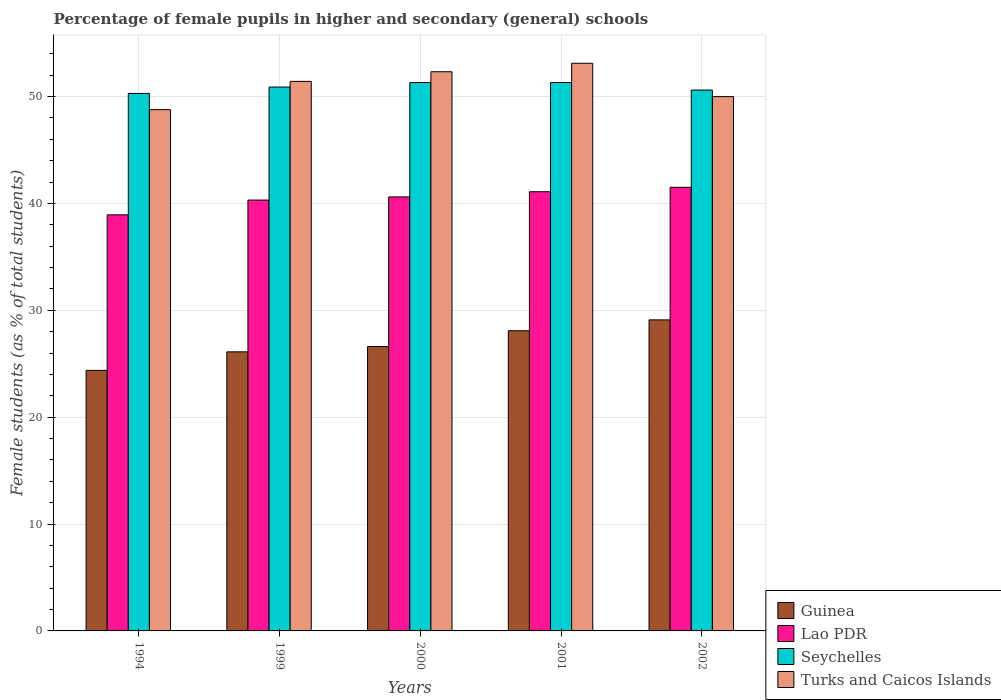How many different coloured bars are there?
Ensure brevity in your answer.  4. Are the number of bars on each tick of the X-axis equal?
Make the answer very short. Yes. How many bars are there on the 2nd tick from the left?
Give a very brief answer. 4. How many bars are there on the 1st tick from the right?
Your response must be concise. 4. What is the label of the 4th group of bars from the left?
Ensure brevity in your answer.  2001. What is the percentage of female pupils in higher and secondary schools in Turks and Caicos Islands in 1994?
Make the answer very short. 48.78. Across all years, what is the maximum percentage of female pupils in higher and secondary schools in Guinea?
Your answer should be very brief. 29.11. Across all years, what is the minimum percentage of female pupils in higher and secondary schools in Guinea?
Your answer should be very brief. 24.38. In which year was the percentage of female pupils in higher and secondary schools in Seychelles maximum?
Make the answer very short. 2000. In which year was the percentage of female pupils in higher and secondary schools in Turks and Caicos Islands minimum?
Ensure brevity in your answer.  1994. What is the total percentage of female pupils in higher and secondary schools in Guinea in the graph?
Your answer should be very brief. 134.31. What is the difference between the percentage of female pupils in higher and secondary schools in Seychelles in 2000 and that in 2001?
Ensure brevity in your answer.  0. What is the difference between the percentage of female pupils in higher and secondary schools in Turks and Caicos Islands in 2002 and the percentage of female pupils in higher and secondary schools in Guinea in 1999?
Offer a terse response. 23.88. What is the average percentage of female pupils in higher and secondary schools in Guinea per year?
Offer a terse response. 26.86. In the year 2000, what is the difference between the percentage of female pupils in higher and secondary schools in Turks and Caicos Islands and percentage of female pupils in higher and secondary schools in Seychelles?
Provide a short and direct response. 1.01. In how many years, is the percentage of female pupils in higher and secondary schools in Guinea greater than 14 %?
Give a very brief answer. 5. What is the ratio of the percentage of female pupils in higher and secondary schools in Lao PDR in 1999 to that in 2002?
Give a very brief answer. 0.97. What is the difference between the highest and the second highest percentage of female pupils in higher and secondary schools in Turks and Caicos Islands?
Ensure brevity in your answer.  0.79. What is the difference between the highest and the lowest percentage of female pupils in higher and secondary schools in Guinea?
Your response must be concise. 4.73. In how many years, is the percentage of female pupils in higher and secondary schools in Seychelles greater than the average percentage of female pupils in higher and secondary schools in Seychelles taken over all years?
Offer a very short reply. 3. What does the 1st bar from the left in 2002 represents?
Make the answer very short. Guinea. What does the 3rd bar from the right in 2002 represents?
Provide a short and direct response. Lao PDR. How many bars are there?
Your response must be concise. 20. What is the difference between two consecutive major ticks on the Y-axis?
Ensure brevity in your answer.  10. Are the values on the major ticks of Y-axis written in scientific E-notation?
Provide a succinct answer. No. Does the graph contain any zero values?
Your answer should be very brief. No. How are the legend labels stacked?
Offer a terse response. Vertical. What is the title of the graph?
Your answer should be compact. Percentage of female pupils in higher and secondary (general) schools. What is the label or title of the X-axis?
Give a very brief answer. Years. What is the label or title of the Y-axis?
Offer a very short reply. Female students (as % of total students). What is the Female students (as % of total students) of Guinea in 1994?
Offer a very short reply. 24.38. What is the Female students (as % of total students) in Lao PDR in 1994?
Offer a terse response. 38.94. What is the Female students (as % of total students) in Seychelles in 1994?
Provide a short and direct response. 50.3. What is the Female students (as % of total students) in Turks and Caicos Islands in 1994?
Provide a succinct answer. 48.78. What is the Female students (as % of total students) of Guinea in 1999?
Provide a short and direct response. 26.12. What is the Female students (as % of total students) of Lao PDR in 1999?
Offer a very short reply. 40.32. What is the Female students (as % of total students) of Seychelles in 1999?
Offer a very short reply. 50.9. What is the Female students (as % of total students) in Turks and Caicos Islands in 1999?
Offer a terse response. 51.43. What is the Female students (as % of total students) of Guinea in 2000?
Provide a short and direct response. 26.61. What is the Female students (as % of total students) in Lao PDR in 2000?
Keep it short and to the point. 40.62. What is the Female students (as % of total students) of Seychelles in 2000?
Provide a short and direct response. 51.32. What is the Female students (as % of total students) of Turks and Caicos Islands in 2000?
Your answer should be very brief. 52.33. What is the Female students (as % of total students) of Guinea in 2001?
Offer a very short reply. 28.09. What is the Female students (as % of total students) of Lao PDR in 2001?
Provide a short and direct response. 41.1. What is the Female students (as % of total students) in Seychelles in 2001?
Your answer should be compact. 51.32. What is the Female students (as % of total students) of Turks and Caicos Islands in 2001?
Make the answer very short. 53.12. What is the Female students (as % of total students) in Guinea in 2002?
Ensure brevity in your answer.  29.11. What is the Female students (as % of total students) in Lao PDR in 2002?
Your answer should be very brief. 41.52. What is the Female students (as % of total students) in Seychelles in 2002?
Provide a short and direct response. 50.61. What is the Female students (as % of total students) in Turks and Caicos Islands in 2002?
Provide a succinct answer. 50. Across all years, what is the maximum Female students (as % of total students) of Guinea?
Offer a very short reply. 29.11. Across all years, what is the maximum Female students (as % of total students) in Lao PDR?
Offer a terse response. 41.52. Across all years, what is the maximum Female students (as % of total students) in Seychelles?
Make the answer very short. 51.32. Across all years, what is the maximum Female students (as % of total students) of Turks and Caicos Islands?
Ensure brevity in your answer.  53.12. Across all years, what is the minimum Female students (as % of total students) of Guinea?
Make the answer very short. 24.38. Across all years, what is the minimum Female students (as % of total students) of Lao PDR?
Your response must be concise. 38.94. Across all years, what is the minimum Female students (as % of total students) of Seychelles?
Make the answer very short. 50.3. Across all years, what is the minimum Female students (as % of total students) of Turks and Caicos Islands?
Ensure brevity in your answer.  48.78. What is the total Female students (as % of total students) in Guinea in the graph?
Give a very brief answer. 134.31. What is the total Female students (as % of total students) of Lao PDR in the graph?
Make the answer very short. 202.49. What is the total Female students (as % of total students) in Seychelles in the graph?
Make the answer very short. 254.44. What is the total Female students (as % of total students) in Turks and Caicos Islands in the graph?
Keep it short and to the point. 255.66. What is the difference between the Female students (as % of total students) of Guinea in 1994 and that in 1999?
Your answer should be very brief. -1.73. What is the difference between the Female students (as % of total students) in Lao PDR in 1994 and that in 1999?
Provide a short and direct response. -1.38. What is the difference between the Female students (as % of total students) in Seychelles in 1994 and that in 1999?
Offer a very short reply. -0.6. What is the difference between the Female students (as % of total students) of Turks and Caicos Islands in 1994 and that in 1999?
Give a very brief answer. -2.65. What is the difference between the Female students (as % of total students) in Guinea in 1994 and that in 2000?
Ensure brevity in your answer.  -2.23. What is the difference between the Female students (as % of total students) in Lao PDR in 1994 and that in 2000?
Ensure brevity in your answer.  -1.68. What is the difference between the Female students (as % of total students) in Seychelles in 1994 and that in 2000?
Provide a succinct answer. -1.02. What is the difference between the Female students (as % of total students) of Turks and Caicos Islands in 1994 and that in 2000?
Offer a terse response. -3.55. What is the difference between the Female students (as % of total students) in Guinea in 1994 and that in 2001?
Your answer should be compact. -3.71. What is the difference between the Female students (as % of total students) in Lao PDR in 1994 and that in 2001?
Offer a very short reply. -2.16. What is the difference between the Female students (as % of total students) of Seychelles in 1994 and that in 2001?
Offer a very short reply. -1.02. What is the difference between the Female students (as % of total students) in Turks and Caicos Islands in 1994 and that in 2001?
Your answer should be compact. -4.34. What is the difference between the Female students (as % of total students) in Guinea in 1994 and that in 2002?
Your answer should be very brief. -4.73. What is the difference between the Female students (as % of total students) of Lao PDR in 1994 and that in 2002?
Your answer should be very brief. -2.58. What is the difference between the Female students (as % of total students) in Seychelles in 1994 and that in 2002?
Your answer should be compact. -0.32. What is the difference between the Female students (as % of total students) in Turks and Caicos Islands in 1994 and that in 2002?
Offer a terse response. -1.22. What is the difference between the Female students (as % of total students) of Guinea in 1999 and that in 2000?
Your answer should be compact. -0.5. What is the difference between the Female students (as % of total students) of Lao PDR in 1999 and that in 2000?
Give a very brief answer. -0.3. What is the difference between the Female students (as % of total students) of Seychelles in 1999 and that in 2000?
Offer a very short reply. -0.42. What is the difference between the Female students (as % of total students) of Turks and Caicos Islands in 1999 and that in 2000?
Provide a short and direct response. -0.9. What is the difference between the Female students (as % of total students) of Guinea in 1999 and that in 2001?
Provide a short and direct response. -1.98. What is the difference between the Female students (as % of total students) of Lao PDR in 1999 and that in 2001?
Offer a terse response. -0.78. What is the difference between the Female students (as % of total students) in Seychelles in 1999 and that in 2001?
Provide a short and direct response. -0.42. What is the difference between the Female students (as % of total students) of Turks and Caicos Islands in 1999 and that in 2001?
Your answer should be compact. -1.7. What is the difference between the Female students (as % of total students) in Guinea in 1999 and that in 2002?
Make the answer very short. -2.99. What is the difference between the Female students (as % of total students) in Lao PDR in 1999 and that in 2002?
Offer a very short reply. -1.2. What is the difference between the Female students (as % of total students) in Seychelles in 1999 and that in 2002?
Your response must be concise. 0.28. What is the difference between the Female students (as % of total students) in Turks and Caicos Islands in 1999 and that in 2002?
Your response must be concise. 1.43. What is the difference between the Female students (as % of total students) of Guinea in 2000 and that in 2001?
Keep it short and to the point. -1.48. What is the difference between the Female students (as % of total students) of Lao PDR in 2000 and that in 2001?
Your answer should be very brief. -0.48. What is the difference between the Female students (as % of total students) in Seychelles in 2000 and that in 2001?
Offer a terse response. 0. What is the difference between the Female students (as % of total students) in Turks and Caicos Islands in 2000 and that in 2001?
Make the answer very short. -0.79. What is the difference between the Female students (as % of total students) of Guinea in 2000 and that in 2002?
Make the answer very short. -2.49. What is the difference between the Female students (as % of total students) of Lao PDR in 2000 and that in 2002?
Your answer should be compact. -0.9. What is the difference between the Female students (as % of total students) of Seychelles in 2000 and that in 2002?
Your answer should be very brief. 0.7. What is the difference between the Female students (as % of total students) in Turks and Caicos Islands in 2000 and that in 2002?
Provide a short and direct response. 2.33. What is the difference between the Female students (as % of total students) in Guinea in 2001 and that in 2002?
Make the answer very short. -1.01. What is the difference between the Female students (as % of total students) in Lao PDR in 2001 and that in 2002?
Your response must be concise. -0.42. What is the difference between the Female students (as % of total students) in Seychelles in 2001 and that in 2002?
Your answer should be very brief. 0.7. What is the difference between the Female students (as % of total students) of Turks and Caicos Islands in 2001 and that in 2002?
Keep it short and to the point. 3.12. What is the difference between the Female students (as % of total students) in Guinea in 1994 and the Female students (as % of total students) in Lao PDR in 1999?
Make the answer very short. -15.94. What is the difference between the Female students (as % of total students) of Guinea in 1994 and the Female students (as % of total students) of Seychelles in 1999?
Give a very brief answer. -26.51. What is the difference between the Female students (as % of total students) of Guinea in 1994 and the Female students (as % of total students) of Turks and Caicos Islands in 1999?
Ensure brevity in your answer.  -27.04. What is the difference between the Female students (as % of total students) of Lao PDR in 1994 and the Female students (as % of total students) of Seychelles in 1999?
Ensure brevity in your answer.  -11.96. What is the difference between the Female students (as % of total students) in Lao PDR in 1994 and the Female students (as % of total students) in Turks and Caicos Islands in 1999?
Make the answer very short. -12.49. What is the difference between the Female students (as % of total students) of Seychelles in 1994 and the Female students (as % of total students) of Turks and Caicos Islands in 1999?
Keep it short and to the point. -1.13. What is the difference between the Female students (as % of total students) of Guinea in 1994 and the Female students (as % of total students) of Lao PDR in 2000?
Your response must be concise. -16.23. What is the difference between the Female students (as % of total students) in Guinea in 1994 and the Female students (as % of total students) in Seychelles in 2000?
Make the answer very short. -26.93. What is the difference between the Female students (as % of total students) of Guinea in 1994 and the Female students (as % of total students) of Turks and Caicos Islands in 2000?
Offer a terse response. -27.95. What is the difference between the Female students (as % of total students) in Lao PDR in 1994 and the Female students (as % of total students) in Seychelles in 2000?
Provide a short and direct response. -12.38. What is the difference between the Female students (as % of total students) in Lao PDR in 1994 and the Female students (as % of total students) in Turks and Caicos Islands in 2000?
Make the answer very short. -13.39. What is the difference between the Female students (as % of total students) of Seychelles in 1994 and the Female students (as % of total students) of Turks and Caicos Islands in 2000?
Your answer should be very brief. -2.03. What is the difference between the Female students (as % of total students) in Guinea in 1994 and the Female students (as % of total students) in Lao PDR in 2001?
Offer a terse response. -16.72. What is the difference between the Female students (as % of total students) of Guinea in 1994 and the Female students (as % of total students) of Seychelles in 2001?
Keep it short and to the point. -26.93. What is the difference between the Female students (as % of total students) of Guinea in 1994 and the Female students (as % of total students) of Turks and Caicos Islands in 2001?
Offer a very short reply. -28.74. What is the difference between the Female students (as % of total students) in Lao PDR in 1994 and the Female students (as % of total students) in Seychelles in 2001?
Give a very brief answer. -12.38. What is the difference between the Female students (as % of total students) of Lao PDR in 1994 and the Female students (as % of total students) of Turks and Caicos Islands in 2001?
Keep it short and to the point. -14.19. What is the difference between the Female students (as % of total students) of Seychelles in 1994 and the Female students (as % of total students) of Turks and Caicos Islands in 2001?
Provide a short and direct response. -2.82. What is the difference between the Female students (as % of total students) in Guinea in 1994 and the Female students (as % of total students) in Lao PDR in 2002?
Offer a very short reply. -17.13. What is the difference between the Female students (as % of total students) of Guinea in 1994 and the Female students (as % of total students) of Seychelles in 2002?
Your answer should be very brief. -26.23. What is the difference between the Female students (as % of total students) of Guinea in 1994 and the Female students (as % of total students) of Turks and Caicos Islands in 2002?
Keep it short and to the point. -25.62. What is the difference between the Female students (as % of total students) of Lao PDR in 1994 and the Female students (as % of total students) of Seychelles in 2002?
Provide a succinct answer. -11.68. What is the difference between the Female students (as % of total students) of Lao PDR in 1994 and the Female students (as % of total students) of Turks and Caicos Islands in 2002?
Your response must be concise. -11.06. What is the difference between the Female students (as % of total students) of Seychelles in 1994 and the Female students (as % of total students) of Turks and Caicos Islands in 2002?
Keep it short and to the point. 0.3. What is the difference between the Female students (as % of total students) of Guinea in 1999 and the Female students (as % of total students) of Lao PDR in 2000?
Your answer should be very brief. -14.5. What is the difference between the Female students (as % of total students) of Guinea in 1999 and the Female students (as % of total students) of Seychelles in 2000?
Provide a short and direct response. -25.2. What is the difference between the Female students (as % of total students) in Guinea in 1999 and the Female students (as % of total students) in Turks and Caicos Islands in 2000?
Provide a succinct answer. -26.21. What is the difference between the Female students (as % of total students) in Lao PDR in 1999 and the Female students (as % of total students) in Seychelles in 2000?
Offer a very short reply. -11. What is the difference between the Female students (as % of total students) in Lao PDR in 1999 and the Female students (as % of total students) in Turks and Caicos Islands in 2000?
Offer a terse response. -12.01. What is the difference between the Female students (as % of total students) of Seychelles in 1999 and the Female students (as % of total students) of Turks and Caicos Islands in 2000?
Your response must be concise. -1.43. What is the difference between the Female students (as % of total students) of Guinea in 1999 and the Female students (as % of total students) of Lao PDR in 2001?
Offer a very short reply. -14.98. What is the difference between the Female students (as % of total students) in Guinea in 1999 and the Female students (as % of total students) in Seychelles in 2001?
Make the answer very short. -25.2. What is the difference between the Female students (as % of total students) in Guinea in 1999 and the Female students (as % of total students) in Turks and Caicos Islands in 2001?
Provide a succinct answer. -27.01. What is the difference between the Female students (as % of total students) of Lao PDR in 1999 and the Female students (as % of total students) of Seychelles in 2001?
Provide a short and direct response. -11. What is the difference between the Female students (as % of total students) in Lao PDR in 1999 and the Female students (as % of total students) in Turks and Caicos Islands in 2001?
Ensure brevity in your answer.  -12.8. What is the difference between the Female students (as % of total students) of Seychelles in 1999 and the Female students (as % of total students) of Turks and Caicos Islands in 2001?
Keep it short and to the point. -2.23. What is the difference between the Female students (as % of total students) in Guinea in 1999 and the Female students (as % of total students) in Lao PDR in 2002?
Provide a short and direct response. -15.4. What is the difference between the Female students (as % of total students) in Guinea in 1999 and the Female students (as % of total students) in Seychelles in 2002?
Keep it short and to the point. -24.5. What is the difference between the Female students (as % of total students) of Guinea in 1999 and the Female students (as % of total students) of Turks and Caicos Islands in 2002?
Your answer should be compact. -23.88. What is the difference between the Female students (as % of total students) in Lao PDR in 1999 and the Female students (as % of total students) in Seychelles in 2002?
Provide a succinct answer. -10.29. What is the difference between the Female students (as % of total students) in Lao PDR in 1999 and the Female students (as % of total students) in Turks and Caicos Islands in 2002?
Provide a short and direct response. -9.68. What is the difference between the Female students (as % of total students) in Seychelles in 1999 and the Female students (as % of total students) in Turks and Caicos Islands in 2002?
Provide a succinct answer. 0.9. What is the difference between the Female students (as % of total students) of Guinea in 2000 and the Female students (as % of total students) of Lao PDR in 2001?
Give a very brief answer. -14.49. What is the difference between the Female students (as % of total students) in Guinea in 2000 and the Female students (as % of total students) in Seychelles in 2001?
Your response must be concise. -24.7. What is the difference between the Female students (as % of total students) in Guinea in 2000 and the Female students (as % of total students) in Turks and Caicos Islands in 2001?
Make the answer very short. -26.51. What is the difference between the Female students (as % of total students) in Lao PDR in 2000 and the Female students (as % of total students) in Seychelles in 2001?
Give a very brief answer. -10.7. What is the difference between the Female students (as % of total students) of Lao PDR in 2000 and the Female students (as % of total students) of Turks and Caicos Islands in 2001?
Ensure brevity in your answer.  -12.51. What is the difference between the Female students (as % of total students) in Seychelles in 2000 and the Female students (as % of total students) in Turks and Caicos Islands in 2001?
Provide a short and direct response. -1.81. What is the difference between the Female students (as % of total students) of Guinea in 2000 and the Female students (as % of total students) of Lao PDR in 2002?
Offer a terse response. -14.9. What is the difference between the Female students (as % of total students) in Guinea in 2000 and the Female students (as % of total students) in Seychelles in 2002?
Offer a terse response. -24. What is the difference between the Female students (as % of total students) in Guinea in 2000 and the Female students (as % of total students) in Turks and Caicos Islands in 2002?
Keep it short and to the point. -23.39. What is the difference between the Female students (as % of total students) in Lao PDR in 2000 and the Female students (as % of total students) in Seychelles in 2002?
Your answer should be compact. -10. What is the difference between the Female students (as % of total students) of Lao PDR in 2000 and the Female students (as % of total students) of Turks and Caicos Islands in 2002?
Your answer should be very brief. -9.38. What is the difference between the Female students (as % of total students) in Seychelles in 2000 and the Female students (as % of total students) in Turks and Caicos Islands in 2002?
Provide a succinct answer. 1.32. What is the difference between the Female students (as % of total students) in Guinea in 2001 and the Female students (as % of total students) in Lao PDR in 2002?
Keep it short and to the point. -13.42. What is the difference between the Female students (as % of total students) of Guinea in 2001 and the Female students (as % of total students) of Seychelles in 2002?
Offer a terse response. -22.52. What is the difference between the Female students (as % of total students) of Guinea in 2001 and the Female students (as % of total students) of Turks and Caicos Islands in 2002?
Your answer should be compact. -21.91. What is the difference between the Female students (as % of total students) of Lao PDR in 2001 and the Female students (as % of total students) of Seychelles in 2002?
Ensure brevity in your answer.  -9.51. What is the difference between the Female students (as % of total students) in Seychelles in 2001 and the Female students (as % of total students) in Turks and Caicos Islands in 2002?
Give a very brief answer. 1.32. What is the average Female students (as % of total students) in Guinea per year?
Provide a short and direct response. 26.86. What is the average Female students (as % of total students) in Lao PDR per year?
Ensure brevity in your answer.  40.5. What is the average Female students (as % of total students) of Seychelles per year?
Your answer should be very brief. 50.89. What is the average Female students (as % of total students) of Turks and Caicos Islands per year?
Your answer should be very brief. 51.13. In the year 1994, what is the difference between the Female students (as % of total students) in Guinea and Female students (as % of total students) in Lao PDR?
Provide a succinct answer. -14.56. In the year 1994, what is the difference between the Female students (as % of total students) in Guinea and Female students (as % of total students) in Seychelles?
Offer a terse response. -25.92. In the year 1994, what is the difference between the Female students (as % of total students) of Guinea and Female students (as % of total students) of Turks and Caicos Islands?
Provide a short and direct response. -24.4. In the year 1994, what is the difference between the Female students (as % of total students) in Lao PDR and Female students (as % of total students) in Seychelles?
Your response must be concise. -11.36. In the year 1994, what is the difference between the Female students (as % of total students) of Lao PDR and Female students (as % of total students) of Turks and Caicos Islands?
Offer a terse response. -9.84. In the year 1994, what is the difference between the Female students (as % of total students) of Seychelles and Female students (as % of total students) of Turks and Caicos Islands?
Offer a very short reply. 1.52. In the year 1999, what is the difference between the Female students (as % of total students) of Guinea and Female students (as % of total students) of Lao PDR?
Provide a short and direct response. -14.2. In the year 1999, what is the difference between the Female students (as % of total students) in Guinea and Female students (as % of total students) in Seychelles?
Ensure brevity in your answer.  -24.78. In the year 1999, what is the difference between the Female students (as % of total students) of Guinea and Female students (as % of total students) of Turks and Caicos Islands?
Your answer should be compact. -25.31. In the year 1999, what is the difference between the Female students (as % of total students) of Lao PDR and Female students (as % of total students) of Seychelles?
Provide a succinct answer. -10.58. In the year 1999, what is the difference between the Female students (as % of total students) of Lao PDR and Female students (as % of total students) of Turks and Caicos Islands?
Your answer should be very brief. -11.11. In the year 1999, what is the difference between the Female students (as % of total students) in Seychelles and Female students (as % of total students) in Turks and Caicos Islands?
Keep it short and to the point. -0.53. In the year 2000, what is the difference between the Female students (as % of total students) of Guinea and Female students (as % of total students) of Lao PDR?
Keep it short and to the point. -14. In the year 2000, what is the difference between the Female students (as % of total students) in Guinea and Female students (as % of total students) in Seychelles?
Offer a terse response. -24.7. In the year 2000, what is the difference between the Female students (as % of total students) of Guinea and Female students (as % of total students) of Turks and Caicos Islands?
Offer a very short reply. -25.72. In the year 2000, what is the difference between the Female students (as % of total students) of Lao PDR and Female students (as % of total students) of Seychelles?
Your response must be concise. -10.7. In the year 2000, what is the difference between the Female students (as % of total students) of Lao PDR and Female students (as % of total students) of Turks and Caicos Islands?
Your answer should be compact. -11.71. In the year 2000, what is the difference between the Female students (as % of total students) of Seychelles and Female students (as % of total students) of Turks and Caicos Islands?
Keep it short and to the point. -1.01. In the year 2001, what is the difference between the Female students (as % of total students) of Guinea and Female students (as % of total students) of Lao PDR?
Ensure brevity in your answer.  -13.01. In the year 2001, what is the difference between the Female students (as % of total students) of Guinea and Female students (as % of total students) of Seychelles?
Provide a succinct answer. -23.22. In the year 2001, what is the difference between the Female students (as % of total students) of Guinea and Female students (as % of total students) of Turks and Caicos Islands?
Your answer should be very brief. -25.03. In the year 2001, what is the difference between the Female students (as % of total students) of Lao PDR and Female students (as % of total students) of Seychelles?
Offer a terse response. -10.22. In the year 2001, what is the difference between the Female students (as % of total students) in Lao PDR and Female students (as % of total students) in Turks and Caicos Islands?
Provide a short and direct response. -12.02. In the year 2001, what is the difference between the Female students (as % of total students) of Seychelles and Female students (as % of total students) of Turks and Caicos Islands?
Give a very brief answer. -1.81. In the year 2002, what is the difference between the Female students (as % of total students) of Guinea and Female students (as % of total students) of Lao PDR?
Your response must be concise. -12.41. In the year 2002, what is the difference between the Female students (as % of total students) of Guinea and Female students (as % of total students) of Seychelles?
Your answer should be very brief. -21.51. In the year 2002, what is the difference between the Female students (as % of total students) in Guinea and Female students (as % of total students) in Turks and Caicos Islands?
Your answer should be very brief. -20.89. In the year 2002, what is the difference between the Female students (as % of total students) of Lao PDR and Female students (as % of total students) of Seychelles?
Offer a very short reply. -9.1. In the year 2002, what is the difference between the Female students (as % of total students) of Lao PDR and Female students (as % of total students) of Turks and Caicos Islands?
Ensure brevity in your answer.  -8.48. In the year 2002, what is the difference between the Female students (as % of total students) in Seychelles and Female students (as % of total students) in Turks and Caicos Islands?
Make the answer very short. 0.61. What is the ratio of the Female students (as % of total students) of Guinea in 1994 to that in 1999?
Give a very brief answer. 0.93. What is the ratio of the Female students (as % of total students) of Lao PDR in 1994 to that in 1999?
Offer a terse response. 0.97. What is the ratio of the Female students (as % of total students) in Seychelles in 1994 to that in 1999?
Give a very brief answer. 0.99. What is the ratio of the Female students (as % of total students) of Turks and Caicos Islands in 1994 to that in 1999?
Provide a succinct answer. 0.95. What is the ratio of the Female students (as % of total students) in Guinea in 1994 to that in 2000?
Keep it short and to the point. 0.92. What is the ratio of the Female students (as % of total students) of Lao PDR in 1994 to that in 2000?
Your response must be concise. 0.96. What is the ratio of the Female students (as % of total students) of Seychelles in 1994 to that in 2000?
Your answer should be compact. 0.98. What is the ratio of the Female students (as % of total students) in Turks and Caicos Islands in 1994 to that in 2000?
Your answer should be compact. 0.93. What is the ratio of the Female students (as % of total students) in Guinea in 1994 to that in 2001?
Keep it short and to the point. 0.87. What is the ratio of the Female students (as % of total students) in Lao PDR in 1994 to that in 2001?
Offer a very short reply. 0.95. What is the ratio of the Female students (as % of total students) in Seychelles in 1994 to that in 2001?
Provide a succinct answer. 0.98. What is the ratio of the Female students (as % of total students) of Turks and Caicos Islands in 1994 to that in 2001?
Provide a short and direct response. 0.92. What is the ratio of the Female students (as % of total students) of Guinea in 1994 to that in 2002?
Your answer should be very brief. 0.84. What is the ratio of the Female students (as % of total students) in Lao PDR in 1994 to that in 2002?
Offer a very short reply. 0.94. What is the ratio of the Female students (as % of total students) of Seychelles in 1994 to that in 2002?
Your answer should be compact. 0.99. What is the ratio of the Female students (as % of total students) of Turks and Caicos Islands in 1994 to that in 2002?
Provide a short and direct response. 0.98. What is the ratio of the Female students (as % of total students) in Guinea in 1999 to that in 2000?
Provide a succinct answer. 0.98. What is the ratio of the Female students (as % of total students) in Seychelles in 1999 to that in 2000?
Your response must be concise. 0.99. What is the ratio of the Female students (as % of total students) in Turks and Caicos Islands in 1999 to that in 2000?
Your response must be concise. 0.98. What is the ratio of the Female students (as % of total students) in Guinea in 1999 to that in 2001?
Your answer should be compact. 0.93. What is the ratio of the Female students (as % of total students) of Turks and Caicos Islands in 1999 to that in 2001?
Ensure brevity in your answer.  0.97. What is the ratio of the Female students (as % of total students) in Guinea in 1999 to that in 2002?
Give a very brief answer. 0.9. What is the ratio of the Female students (as % of total students) of Lao PDR in 1999 to that in 2002?
Ensure brevity in your answer.  0.97. What is the ratio of the Female students (as % of total students) in Seychelles in 1999 to that in 2002?
Your answer should be compact. 1.01. What is the ratio of the Female students (as % of total students) of Turks and Caicos Islands in 1999 to that in 2002?
Your response must be concise. 1.03. What is the ratio of the Female students (as % of total students) of Guinea in 2000 to that in 2001?
Keep it short and to the point. 0.95. What is the ratio of the Female students (as % of total students) of Turks and Caicos Islands in 2000 to that in 2001?
Make the answer very short. 0.99. What is the ratio of the Female students (as % of total students) in Guinea in 2000 to that in 2002?
Your answer should be compact. 0.91. What is the ratio of the Female students (as % of total students) in Lao PDR in 2000 to that in 2002?
Your answer should be compact. 0.98. What is the ratio of the Female students (as % of total students) of Seychelles in 2000 to that in 2002?
Give a very brief answer. 1.01. What is the ratio of the Female students (as % of total students) in Turks and Caicos Islands in 2000 to that in 2002?
Make the answer very short. 1.05. What is the ratio of the Female students (as % of total students) of Guinea in 2001 to that in 2002?
Your answer should be compact. 0.97. What is the ratio of the Female students (as % of total students) in Lao PDR in 2001 to that in 2002?
Your answer should be very brief. 0.99. What is the ratio of the Female students (as % of total students) in Seychelles in 2001 to that in 2002?
Keep it short and to the point. 1.01. What is the ratio of the Female students (as % of total students) of Turks and Caicos Islands in 2001 to that in 2002?
Your response must be concise. 1.06. What is the difference between the highest and the second highest Female students (as % of total students) of Guinea?
Ensure brevity in your answer.  1.01. What is the difference between the highest and the second highest Female students (as % of total students) in Lao PDR?
Keep it short and to the point. 0.42. What is the difference between the highest and the second highest Female students (as % of total students) of Seychelles?
Provide a succinct answer. 0. What is the difference between the highest and the second highest Female students (as % of total students) of Turks and Caicos Islands?
Your answer should be very brief. 0.79. What is the difference between the highest and the lowest Female students (as % of total students) in Guinea?
Provide a short and direct response. 4.73. What is the difference between the highest and the lowest Female students (as % of total students) of Lao PDR?
Your answer should be compact. 2.58. What is the difference between the highest and the lowest Female students (as % of total students) of Seychelles?
Provide a succinct answer. 1.02. What is the difference between the highest and the lowest Female students (as % of total students) in Turks and Caicos Islands?
Provide a succinct answer. 4.34. 